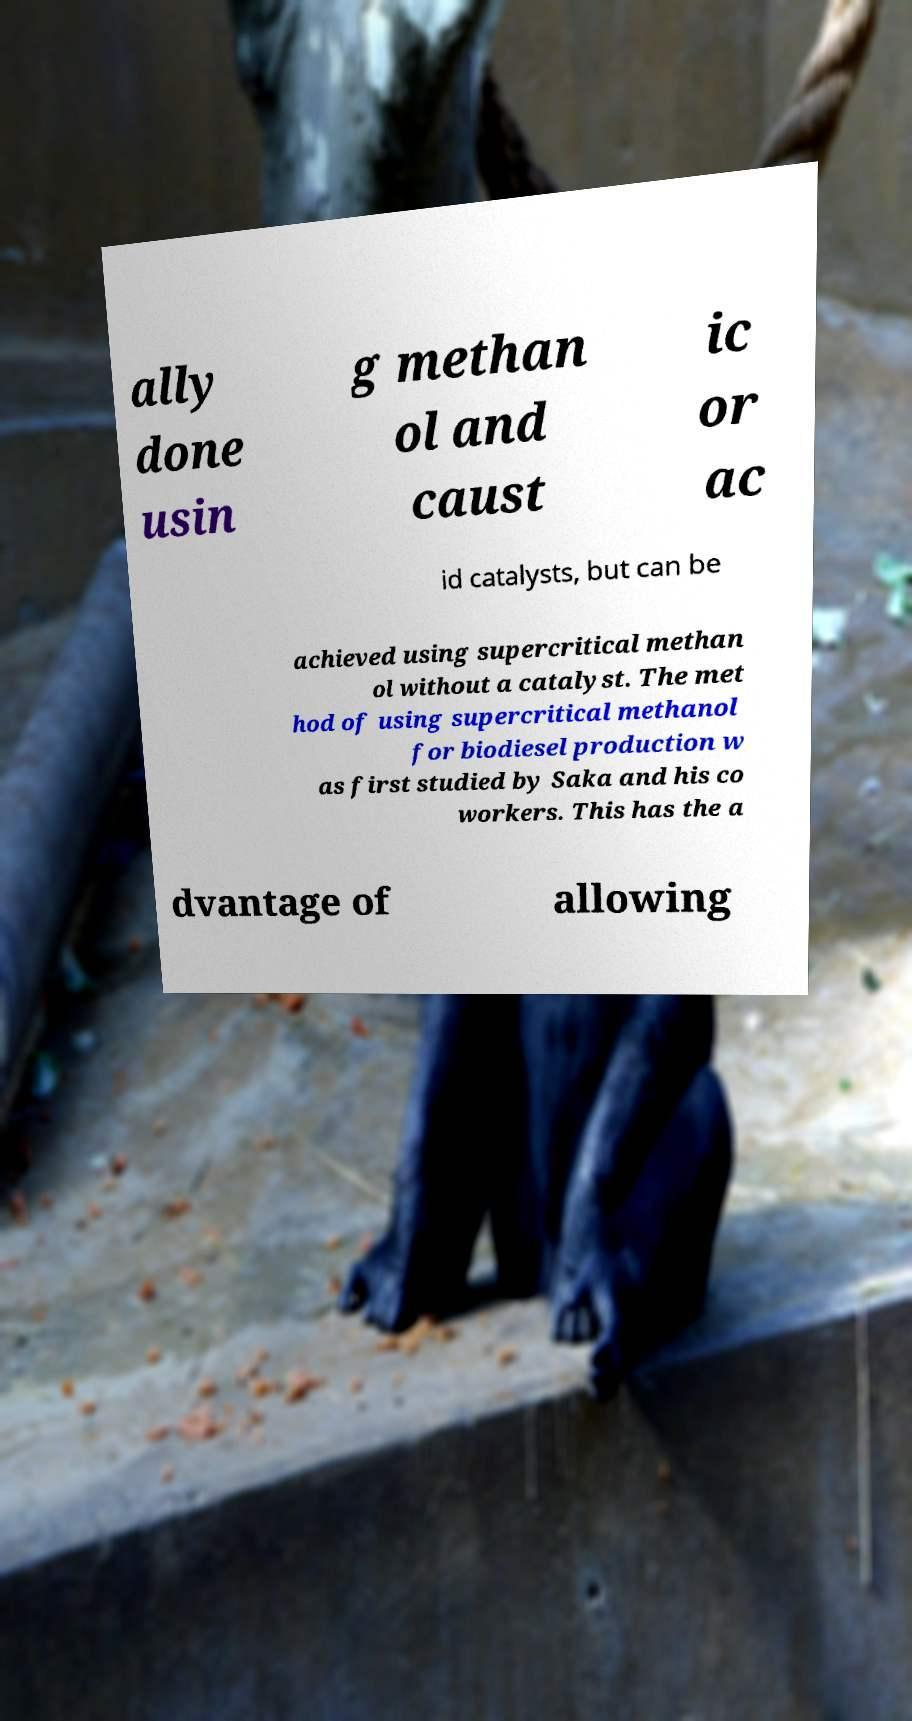I need the written content from this picture converted into text. Can you do that? ally done usin g methan ol and caust ic or ac id catalysts, but can be achieved using supercritical methan ol without a catalyst. The met hod of using supercritical methanol for biodiesel production w as first studied by Saka and his co workers. This has the a dvantage of allowing 